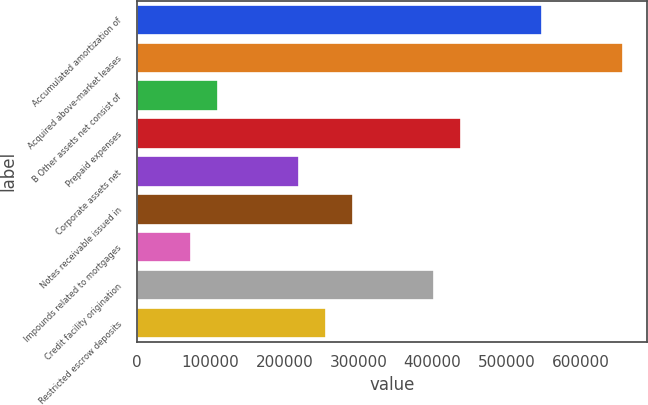Convert chart to OTSL. <chart><loc_0><loc_0><loc_500><loc_500><bar_chart><fcel>Accumulated amortization of<fcel>Acquired above-market leases<fcel>B Other assets net consist of<fcel>Prepaid expenses<fcel>Corporate assets net<fcel>Notes receivable issued in<fcel>Impounds related to mortgages<fcel>Credit facility origination<fcel>Restricted escrow deposits<nl><fcel>547466<fcel>656943<fcel>109559<fcel>437990<fcel>219036<fcel>292020<fcel>73066.6<fcel>401497<fcel>255528<nl></chart> 